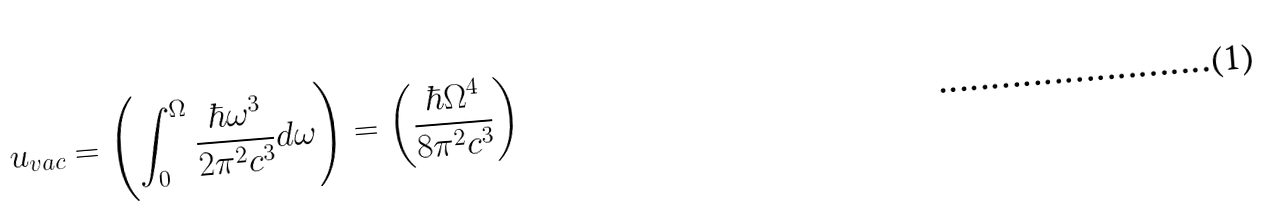Convert formula to latex. <formula><loc_0><loc_0><loc_500><loc_500>u _ { v a c } = \left ( \int _ { 0 } ^ { \Omega } \frac { \hbar { \omega } ^ { 3 } } { 2 \pi ^ { 2 } c ^ { 3 } } d \omega \right ) = \left ( \frac { \hbar { \Omega } ^ { 4 } } { 8 \pi ^ { 2 } c ^ { 3 } } \right )</formula> 